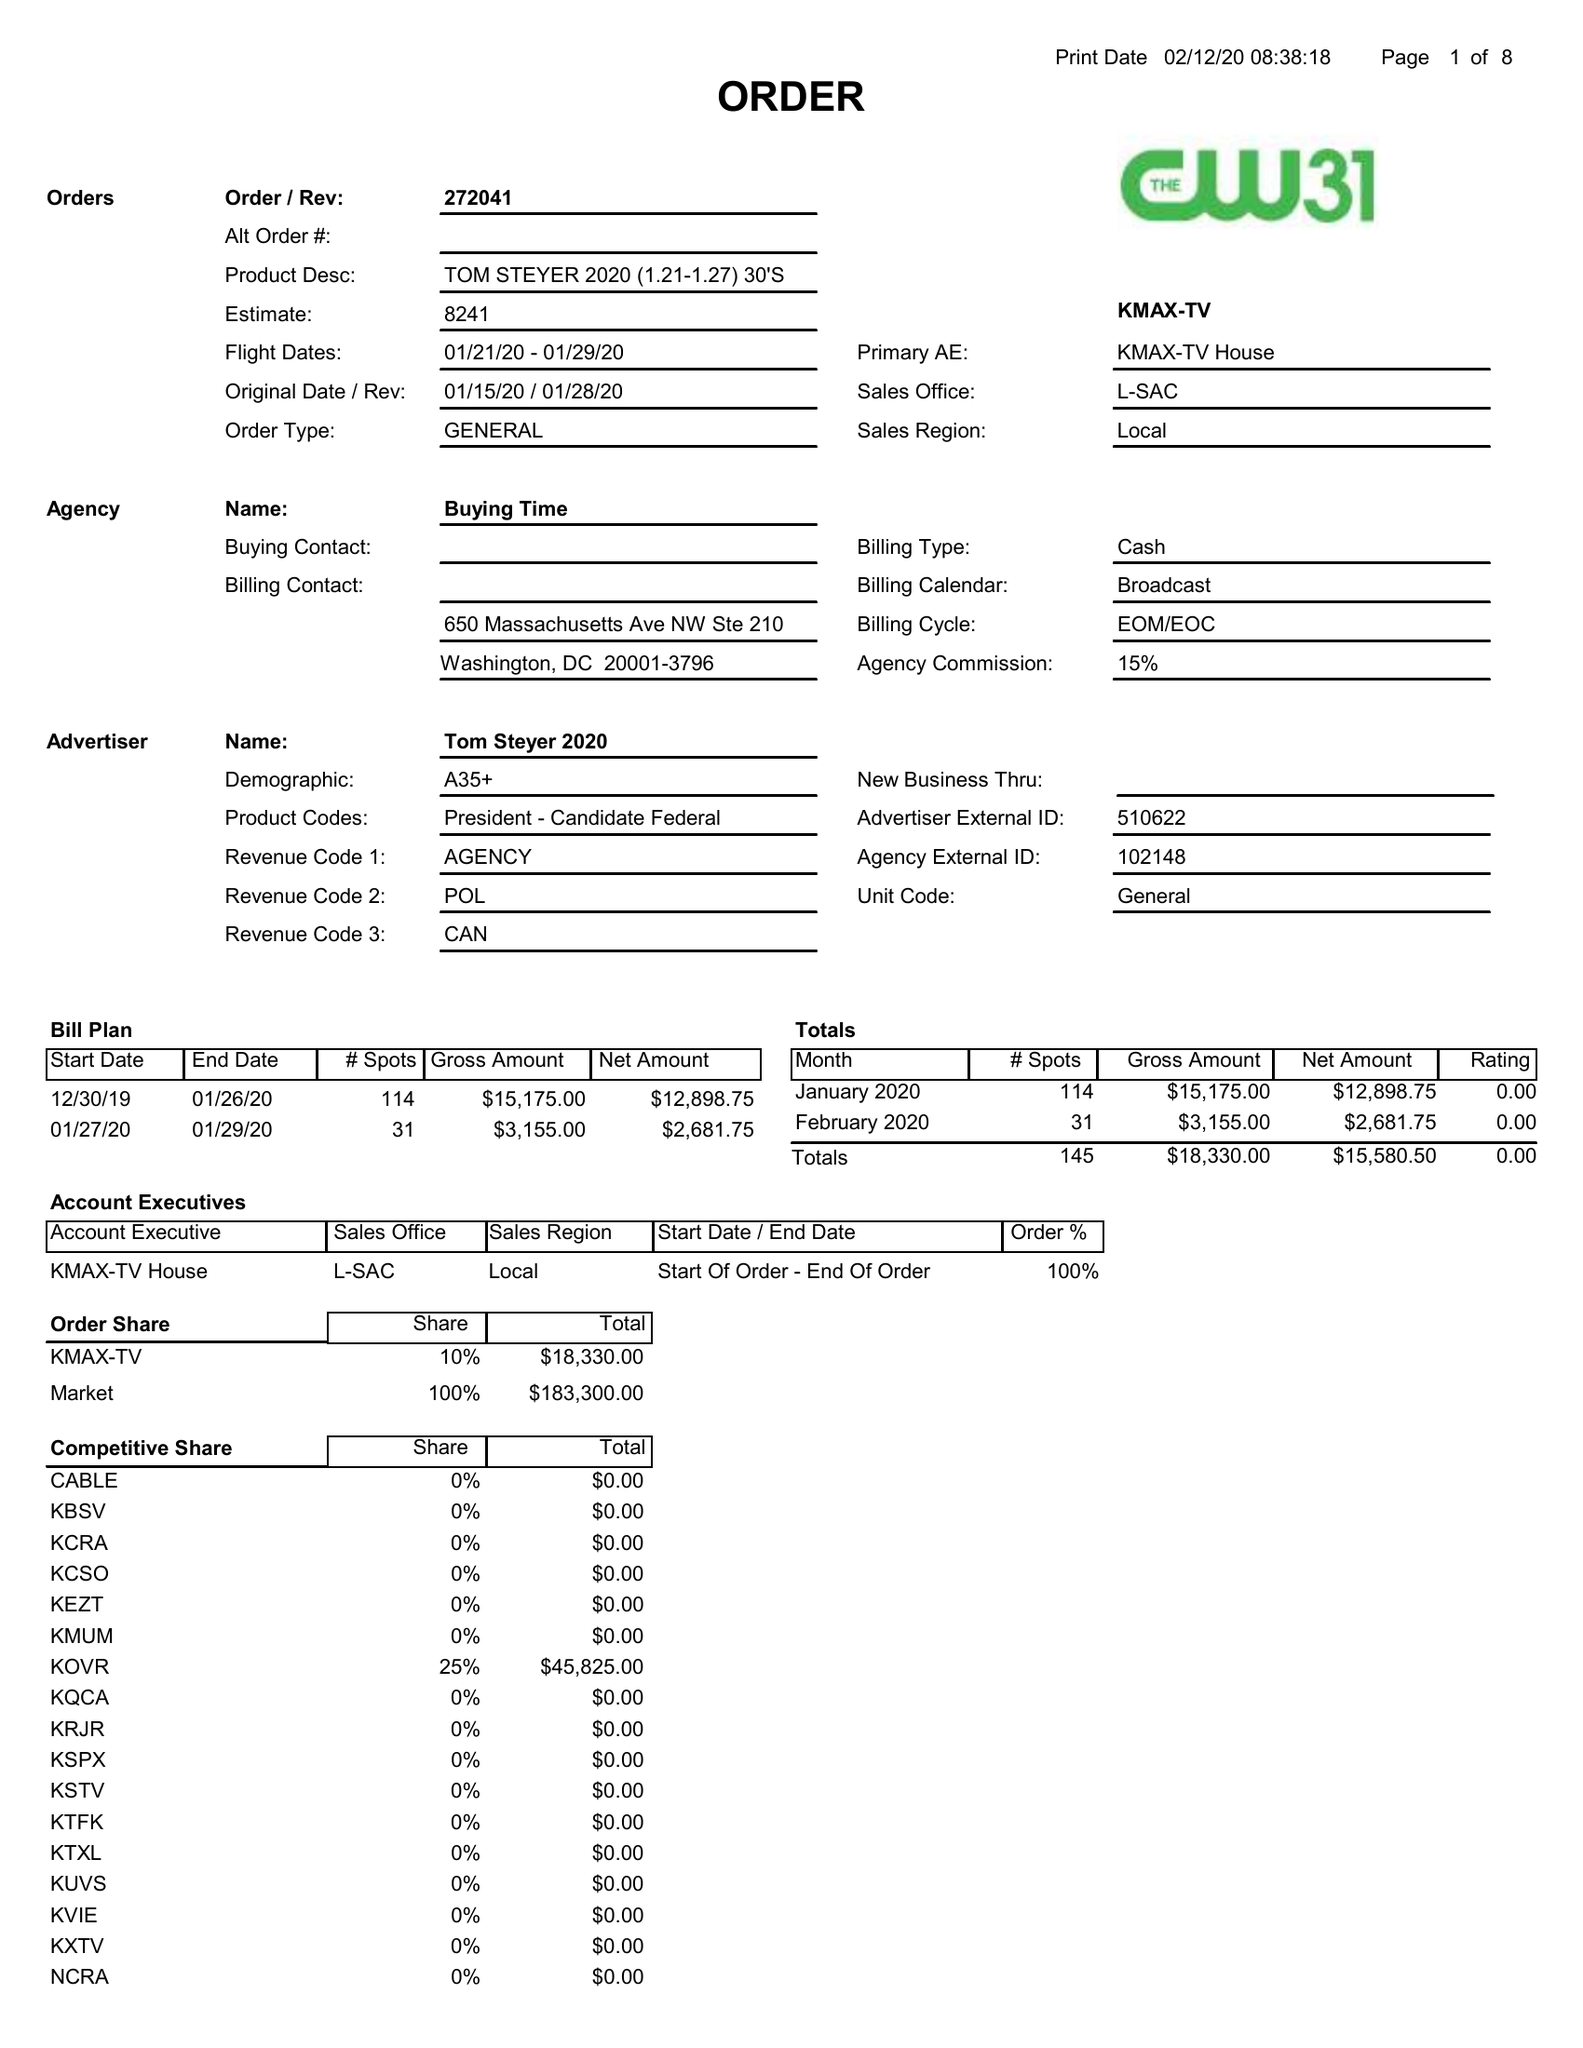What is the value for the flight_from?
Answer the question using a single word or phrase. 01/21/20 